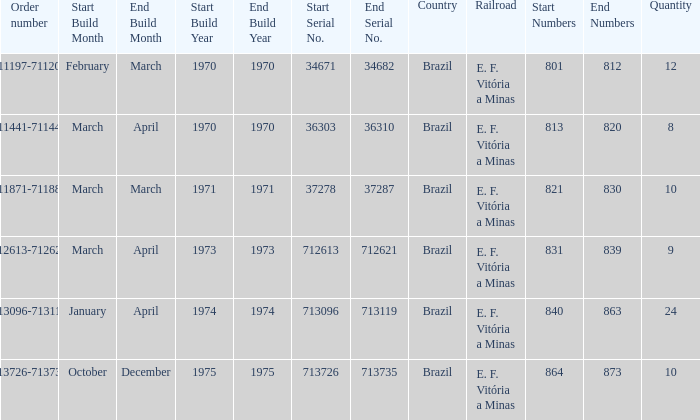The serial numbers 713096-713119 are in which country? Brazil. 